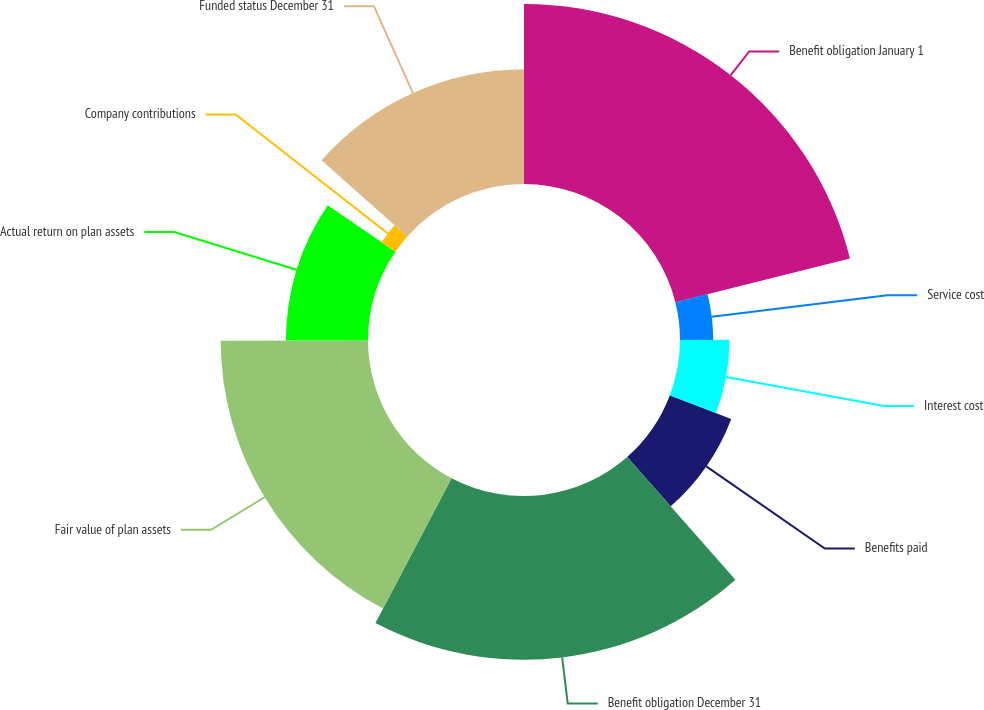Convert chart to OTSL. <chart><loc_0><loc_0><loc_500><loc_500><pie_chart><fcel>Benefit obligation January 1<fcel>Service cost<fcel>Interest cost<fcel>Benefits paid<fcel>Benefit obligation December 31<fcel>Fair value of plan assets<fcel>Actual return on plan assets<fcel>Company contributions<fcel>Funded status December 31<nl><fcel>21.1%<fcel>3.89%<fcel>5.8%<fcel>7.71%<fcel>19.19%<fcel>17.27%<fcel>9.62%<fcel>1.97%<fcel>13.45%<nl></chart> 